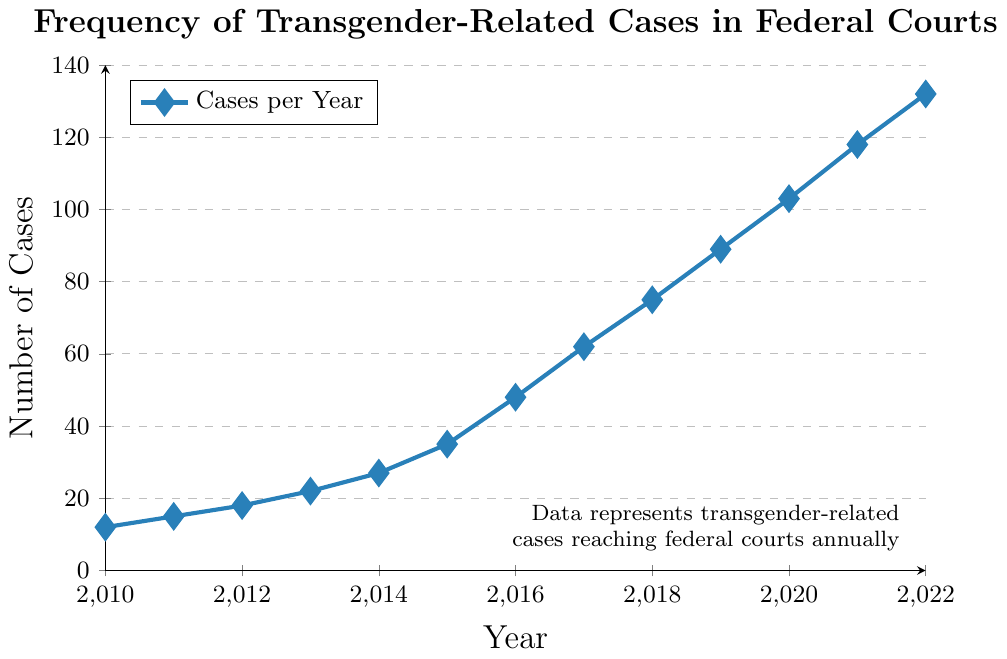What is the lowest number of transgender-related cases in federal courts for the years shown? The lowest number of cases shown on the graph is from the year 2010. By examining the vertical position at that point, it corresponds to 12 cases.
Answer: 12 What was the increase in the number of cases from 2010 to 2011? The number of cases in 2010 was 12, and in 2011 it was 15. The increase is found by subtracting 12 from 15.
Answer: 3 Which year had the highest number of transgender-related cases in federal courts? Observing the chart, the highest value is reached in 2022, where the count is at its peak.
Answer: 2022 How does the number of cases in 2015 compare to 2019? In 2015, the number of cases was 35; in 2019, it was 89. By comparing these two years, 2019 had more cases.
Answer: 2019 had more cases What is the average number of cases from 2016 to 2018? First, sum the cases from 2016 to 2018: 48 (2016) + 62 (2017) + 75 (2018) = 185. Then divide by the number of years, which is 3, to find the average.
Answer: 61.67 Did the number of cases ever decrease from one year to the next in this period? By inspecting the graph, we see that the trend is consistently upward with no downward movement, so the number of cases never decreased year over year.
Answer: No What is the relative increase in cases from 2013 to 2022? In 2013, the number of cases was 22, and in 2022 it was 132. The relative increase is found by subtracting 22 from 132, then dividing by 22, and multiplying by 100 to get the percentage. \((132 - 22) / 22 * 100 = 500\)%
Answer: 500% By how much did the number of cases rise from 2018 to 2020? The number of cases in 2018 was 75, and in 2020, it was 103. Subtracting 75 from 103 identifies the increase.
Answer: 28 What is the median number of cases over the entire period shown? Arrange the numbers in ascending order: 12, 15, 18, 22, 27, 35, 48, 62, 75, 89, 103, 118, 132. The median is the middle number in this ordered list, which for 13 numbers is the seventh value.
Answer: 48 Which year had a greater number of cases, 2017 or 2021? For 2017, the graph shows 62 cases, and for 2021, it shows 118 cases. By comparing these two values, 2021 has a greater number of cases.
Answer: 2021 